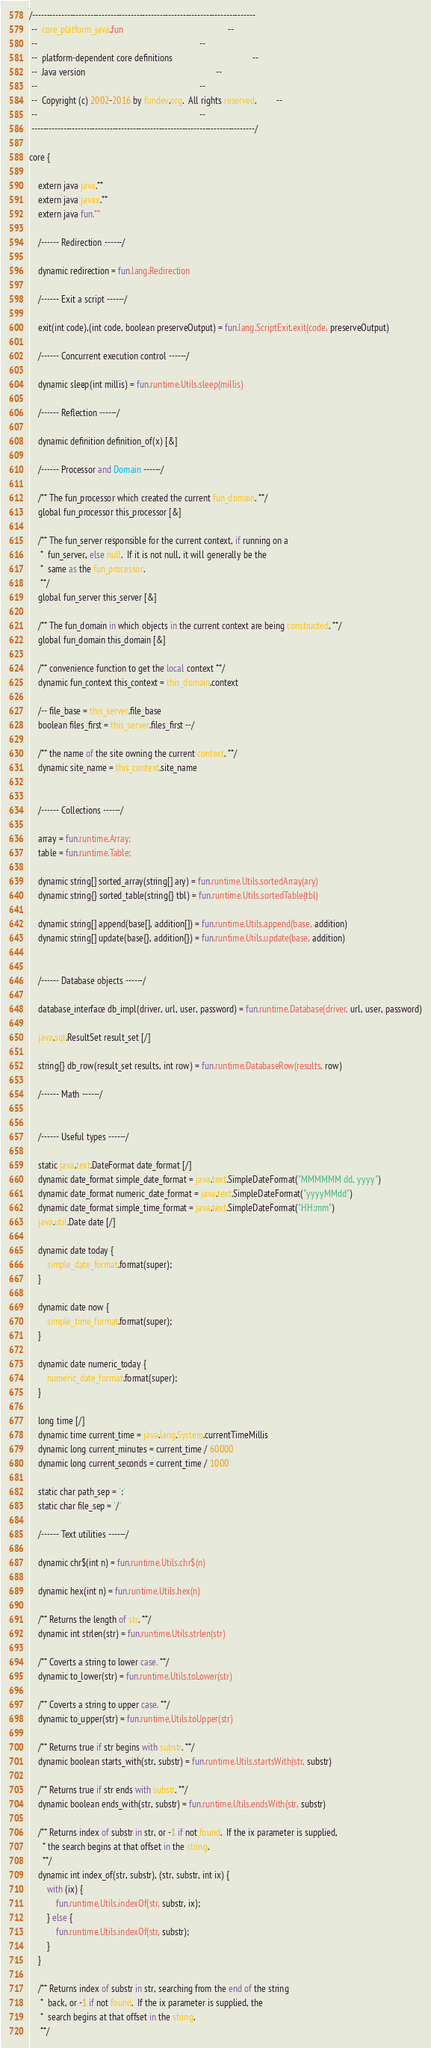<code> <loc_0><loc_0><loc_500><loc_500><_SML_>/-----------------------------------------------------------------------------
 --  core_platform_java.fun                                               --
 --                                                                         --
 --  platform-dependent core definitions                                    --
 --  Java version                                                           --
 --                                                                         --
 --  Copyright (c) 2002-2016 by fundev.org.  All rights reserved.         --
 --                                                                         --
 -----------------------------------------------------------------------------/

core {

    extern java java.**
    extern java javax.**
    extern java fun.**

    /------ Redirection ------/
    
    dynamic redirection = fun.lang.Redirection

    /------ Exit a script ------/
    
    exit(int code),(int code, boolean preserveOutput) = fun.lang.ScriptExit.exit(code, preserveOutput)

    /------ Concurrent execution control ------/
    
    dynamic sleep(int millis) = fun.runtime.Utils.sleep(millis)

    /------ Reflection ------/

    dynamic definition definition_of(x) [&]

    /------ Processor and Domain ------/

    /** The fun_processor which created the current fun_domain. **/
    global fun_processor this_processor [&]

    /** The fun_server responsible for the current context, if running on a
     *  fun_server, else null.  If it is not null, it will generally be the 
     *  same as the fun_processor.
     **/
    global fun_server this_server [&]

    /** The fun_domain in which objects in the current context are being constructed. **/
    global fun_domain this_domain [&]
    
    /** convenience function to get the local context **/
    dynamic fun_context this_context = this_domain.context

	/-- file_base = this_server.file_base
	boolean files_first = this_server.files_first --/

    /** the name of the site owning the current context. **/
	dynamic site_name = this_context.site_name


    /------ Collections ------/

    array = fun.runtime.Array;
    table = fun.runtime.Table;
    
    dynamic string[] sorted_array(string[] ary) = fun.runtime.Utils.sortedArray(ary)
    dynamic string{} sorted_table(string{} tbl) = fun.runtime.Utils.sortedTable(tbl) 

    dynamic string[] append(base[], addition[]) = fun.runtime.Utils.append(base, addition)
    dynamic string[] update(base{}, addition{}) = fun.runtime.Utils.update(base, addition)


    /------ Database objects ------/

    database_interface db_impl(driver, url, user, password) = fun.runtime.Database(driver, url, user, password)

    java.sql.ResultSet result_set [/]

    string{} db_row(result_set results, int row) = fun.runtime.DatabaseRow(results, row)

    /------ Math ------/
    

    /------ Useful types ------/

    static java.text.DateFormat date_format [/]
    dynamic date_format simple_date_format = java.text.SimpleDateFormat("MMMMMM dd, yyyy")
    dynamic date_format numeric_date_format = java.text.SimpleDateFormat("yyyyMMdd")
    dynamic date_format simple_time_format = java.text.SimpleDateFormat("HH:mm")
    java.util.Date date [/]

    dynamic date today {
        simple_date_format.format(super);
    }

    dynamic date now {
        simple_time_format.format(super);
    }

    dynamic date numeric_today {
        numeric_date_format.format(super);
    }

    long time [/]
    dynamic time current_time = java.lang.System.currentTimeMillis
    dynamic long current_minutes = current_time / 60000
    dynamic long current_seconds = current_time / 1000

    static char path_sep = ':'
    static char file_sep = '/'

    /------ Text utilities ------/
    
    dynamic chr$(int n) = fun.runtime.Utils.chr$(n)

    dynamic hex(int n) = fun.runtime.Utils.hex(n)

	/** Returns the length of str. **/
	dynamic int strlen(str) = fun.runtime.Utils.strlen(str)

    /** Coverts a string to lower case. **/
    dynamic to_lower(str) = fun.runtime.Utils.toLower(str)

    /** Coverts a string to upper case. **/
    dynamic to_upper(str) = fun.runtime.Utils.toUpper(str)

    /** Returns true if str begins with substr. **/
    dynamic boolean starts_with(str, substr) = fun.runtime.Utils.startsWith(str, substr)

    /** Returns true if str ends with substr. **/
    dynamic boolean ends_with(str, substr) = fun.runtime.Utils.endsWith(str, substr)
    
    /** Returns index of substr in str, or -1 if not found.  If the ix parameter is supplied,
      * the search begins at that offset in the string.
      **/
    dynamic int index_of(str, substr), (str, substr, int ix) { 
        with (ix) {
            fun.runtime.Utils.indexOf(str, substr, ix);
        } else {
            fun.runtime.Utils.indexOf(str, substr);
        }
    }

    /** Returns index of substr in str, searching from the end of the string
     *  back, or -1 if not found.  If the ix parameter is supplied, the 
     *  search begins at that offset in the string.
     **/</code> 